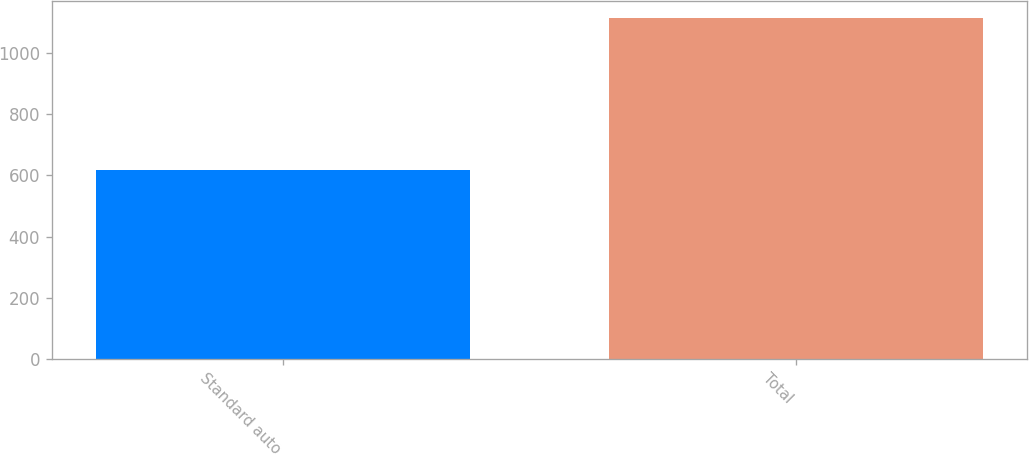Convert chart to OTSL. <chart><loc_0><loc_0><loc_500><loc_500><bar_chart><fcel>Standard auto<fcel>Total<nl><fcel>618<fcel>1113<nl></chart> 